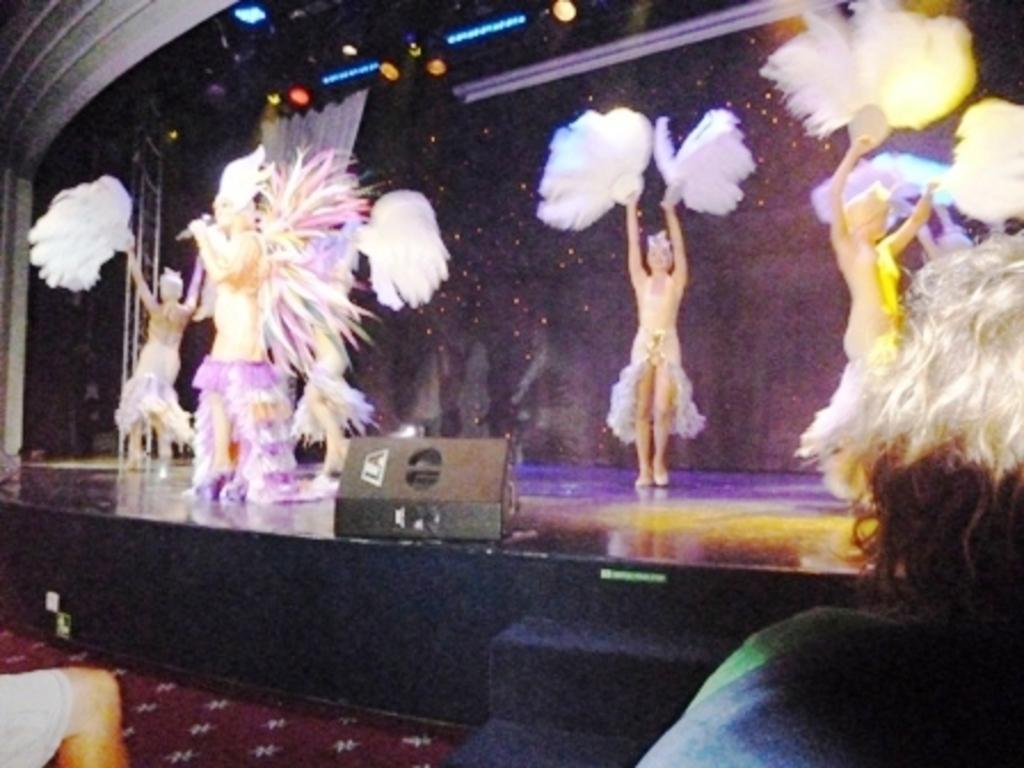Please provide a concise description of this image. This picture is clicked inside. In the foreground we can see the two persons. In the center there is an object and we can see the group of people dancing. In the background we can see the focusing lights, metal rods and a curtain. 